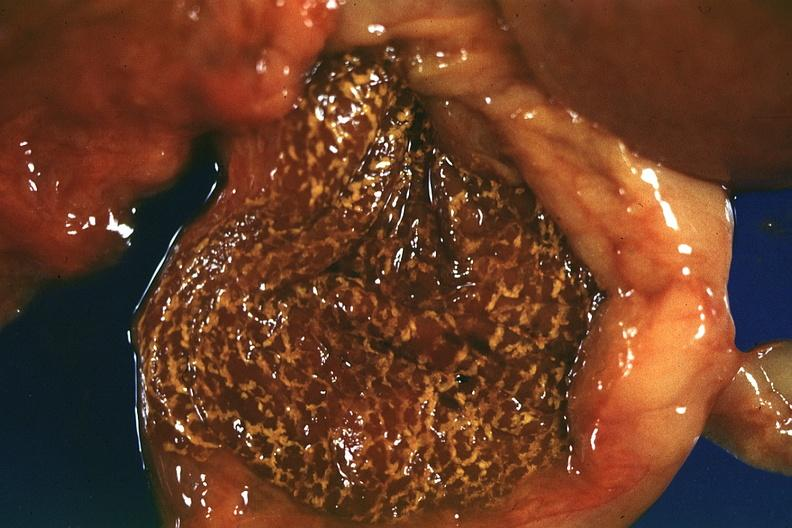s liver present?
Answer the question using a single word or phrase. Yes 